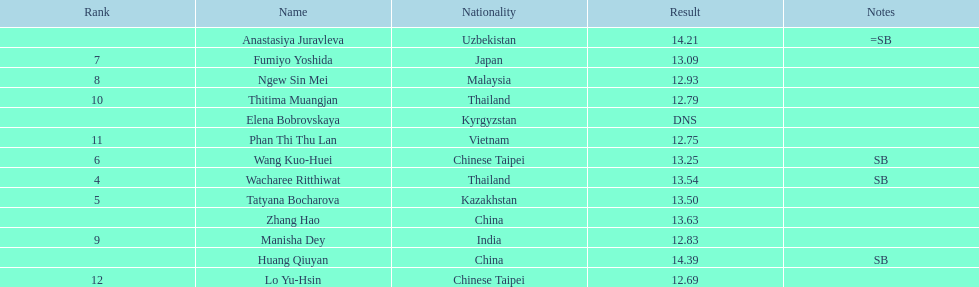How many points apart were the 1st place competitor and the 12th place competitor? 1.7. 